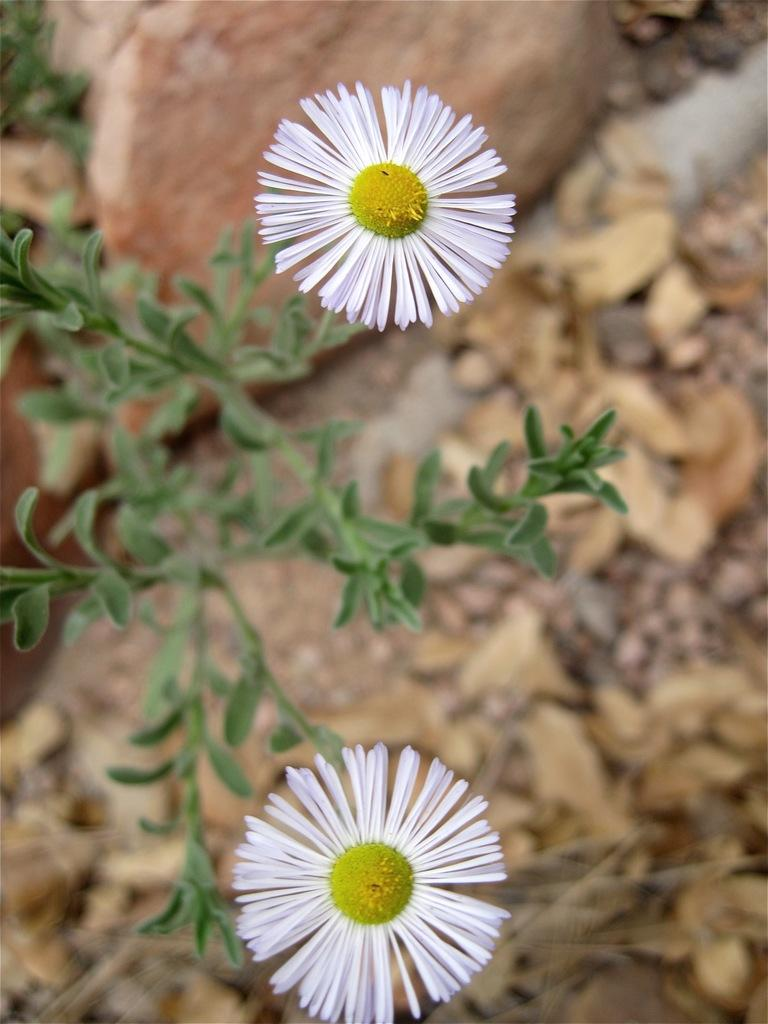What type of living organisms can be seen in the image? There are flowers and plants in the image. Can you describe the flowers in the image? Unfortunately, the facts provided do not give specific details about the flowers. What is the relationship between the flowers and plants in the image? Both flowers and plants are types of vegetation, and they may be growing together or separately in the image. Reasoning: Let's think step by step by step in order to produce the conversation. We start by identifying the main subjects in the image, which are flowers and plants. Then, we formulate questions that focus on the characteristics of these subjects, ensuring that each question can be answered definitively with the information given. We avoid yes/no questions and ensure that the language is simple and clear. Absurd Question/Answer: What color is the butter on the sweater in the image? There is no butter or sweater present in the image; it only features flowers and plants. What type of cake is being served at the birthday party in the image? There is no cake or birthday party present in the image; it only features flowers and plants. 